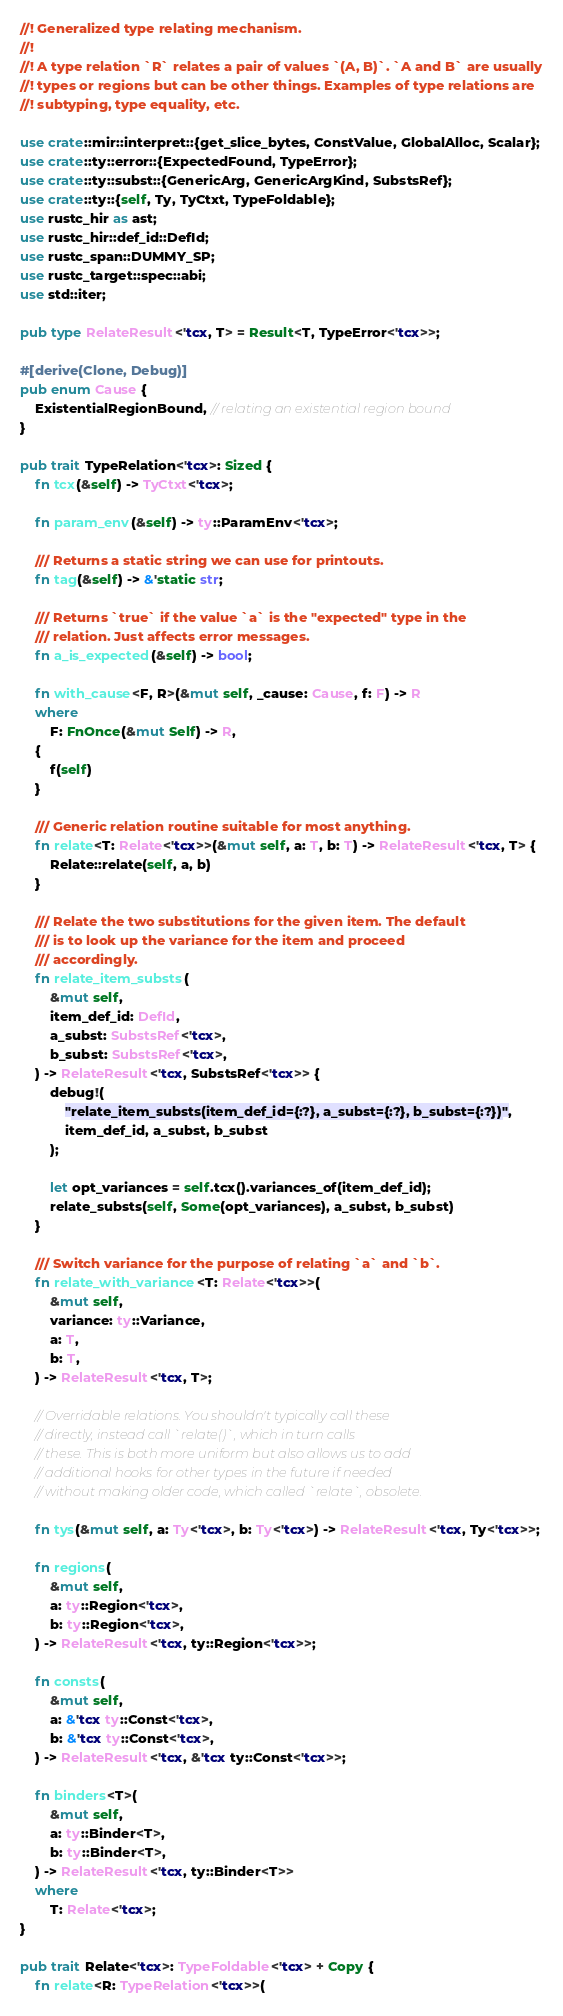Convert code to text. <code><loc_0><loc_0><loc_500><loc_500><_Rust_>//! Generalized type relating mechanism.
//!
//! A type relation `R` relates a pair of values `(A, B)`. `A and B` are usually
//! types or regions but can be other things. Examples of type relations are
//! subtyping, type equality, etc.

use crate::mir::interpret::{get_slice_bytes, ConstValue, GlobalAlloc, Scalar};
use crate::ty::error::{ExpectedFound, TypeError};
use crate::ty::subst::{GenericArg, GenericArgKind, SubstsRef};
use crate::ty::{self, Ty, TyCtxt, TypeFoldable};
use rustc_hir as ast;
use rustc_hir::def_id::DefId;
use rustc_span::DUMMY_SP;
use rustc_target::spec::abi;
use std::iter;

pub type RelateResult<'tcx, T> = Result<T, TypeError<'tcx>>;

#[derive(Clone, Debug)]
pub enum Cause {
    ExistentialRegionBound, // relating an existential region bound
}

pub trait TypeRelation<'tcx>: Sized {
    fn tcx(&self) -> TyCtxt<'tcx>;

    fn param_env(&self) -> ty::ParamEnv<'tcx>;

    /// Returns a static string we can use for printouts.
    fn tag(&self) -> &'static str;

    /// Returns `true` if the value `a` is the "expected" type in the
    /// relation. Just affects error messages.
    fn a_is_expected(&self) -> bool;

    fn with_cause<F, R>(&mut self, _cause: Cause, f: F) -> R
    where
        F: FnOnce(&mut Self) -> R,
    {
        f(self)
    }

    /// Generic relation routine suitable for most anything.
    fn relate<T: Relate<'tcx>>(&mut self, a: T, b: T) -> RelateResult<'tcx, T> {
        Relate::relate(self, a, b)
    }

    /// Relate the two substitutions for the given item. The default
    /// is to look up the variance for the item and proceed
    /// accordingly.
    fn relate_item_substs(
        &mut self,
        item_def_id: DefId,
        a_subst: SubstsRef<'tcx>,
        b_subst: SubstsRef<'tcx>,
    ) -> RelateResult<'tcx, SubstsRef<'tcx>> {
        debug!(
            "relate_item_substs(item_def_id={:?}, a_subst={:?}, b_subst={:?})",
            item_def_id, a_subst, b_subst
        );

        let opt_variances = self.tcx().variances_of(item_def_id);
        relate_substs(self, Some(opt_variances), a_subst, b_subst)
    }

    /// Switch variance for the purpose of relating `a` and `b`.
    fn relate_with_variance<T: Relate<'tcx>>(
        &mut self,
        variance: ty::Variance,
        a: T,
        b: T,
    ) -> RelateResult<'tcx, T>;

    // Overridable relations. You shouldn't typically call these
    // directly, instead call `relate()`, which in turn calls
    // these. This is both more uniform but also allows us to add
    // additional hooks for other types in the future if needed
    // without making older code, which called `relate`, obsolete.

    fn tys(&mut self, a: Ty<'tcx>, b: Ty<'tcx>) -> RelateResult<'tcx, Ty<'tcx>>;

    fn regions(
        &mut self,
        a: ty::Region<'tcx>,
        b: ty::Region<'tcx>,
    ) -> RelateResult<'tcx, ty::Region<'tcx>>;

    fn consts(
        &mut self,
        a: &'tcx ty::Const<'tcx>,
        b: &'tcx ty::Const<'tcx>,
    ) -> RelateResult<'tcx, &'tcx ty::Const<'tcx>>;

    fn binders<T>(
        &mut self,
        a: ty::Binder<T>,
        b: ty::Binder<T>,
    ) -> RelateResult<'tcx, ty::Binder<T>>
    where
        T: Relate<'tcx>;
}

pub trait Relate<'tcx>: TypeFoldable<'tcx> + Copy {
    fn relate<R: TypeRelation<'tcx>>(</code> 